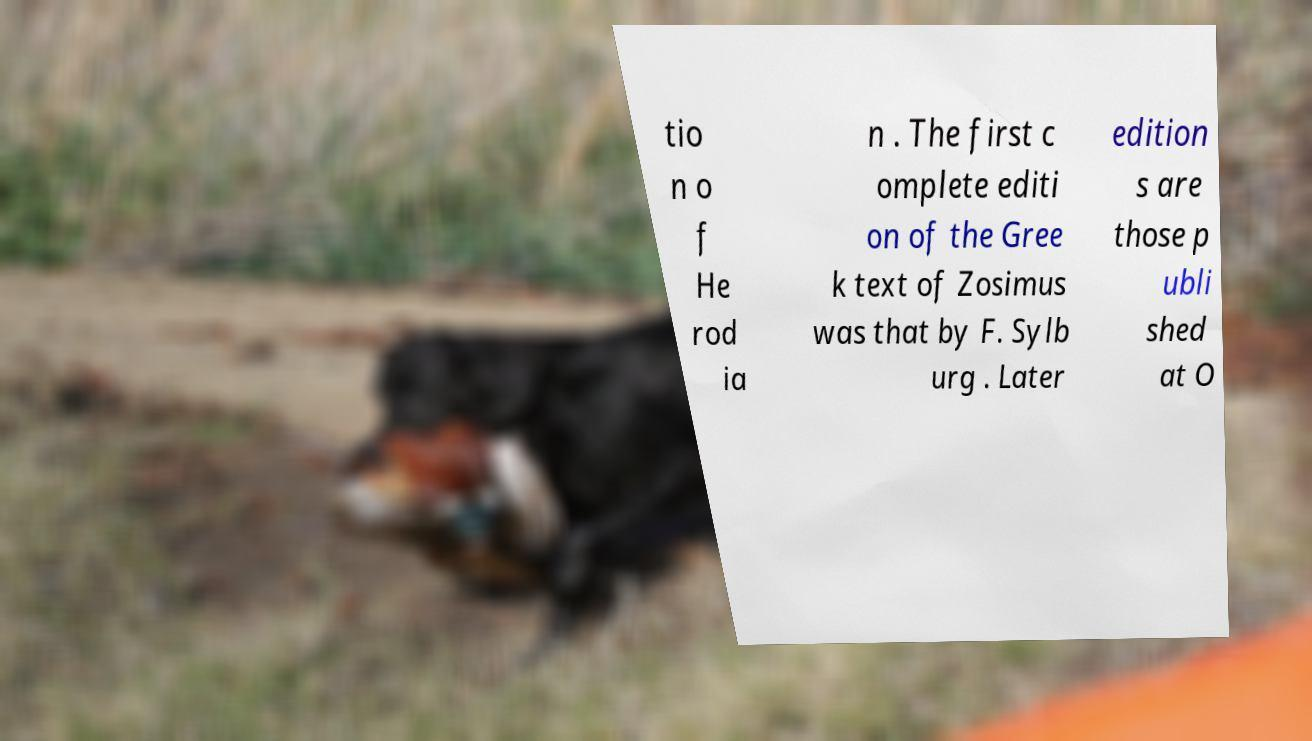Can you accurately transcribe the text from the provided image for me? tio n o f He rod ia n . The first c omplete editi on of the Gree k text of Zosimus was that by F. Sylb urg . Later edition s are those p ubli shed at O 